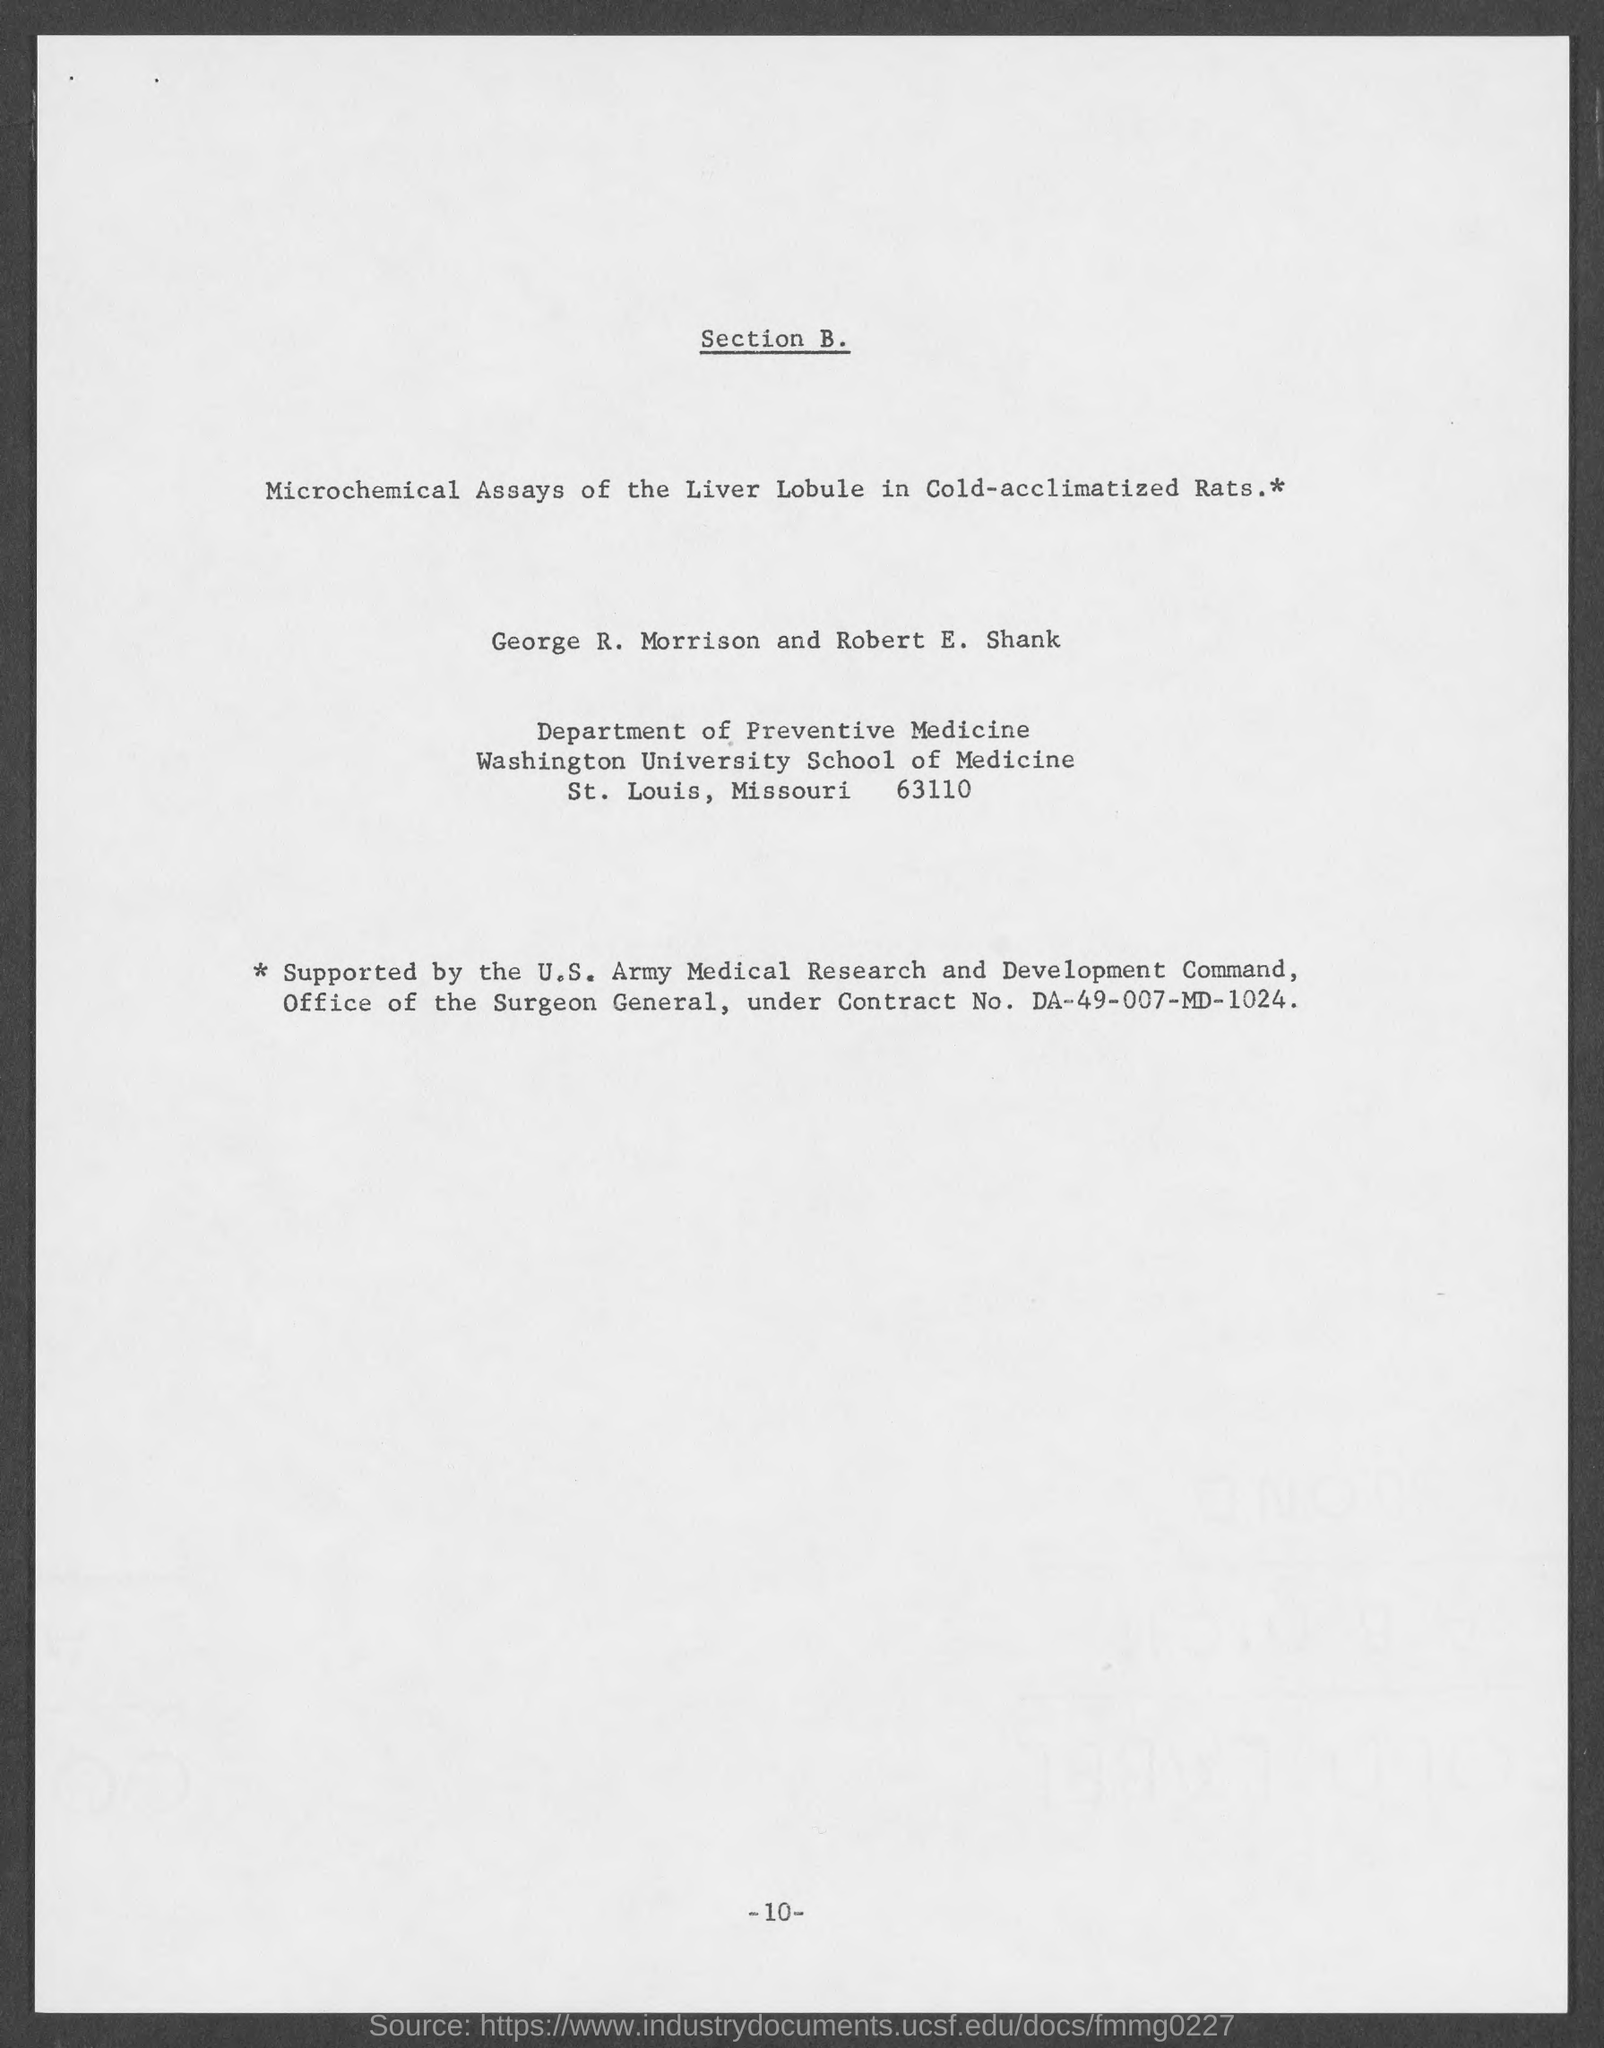Identify some key points in this picture. Robert E. Shank is currently affiliated with the Washington University School of Medicine. I am not able to provide the page number at the bottom of the page, as it is -10-.. 